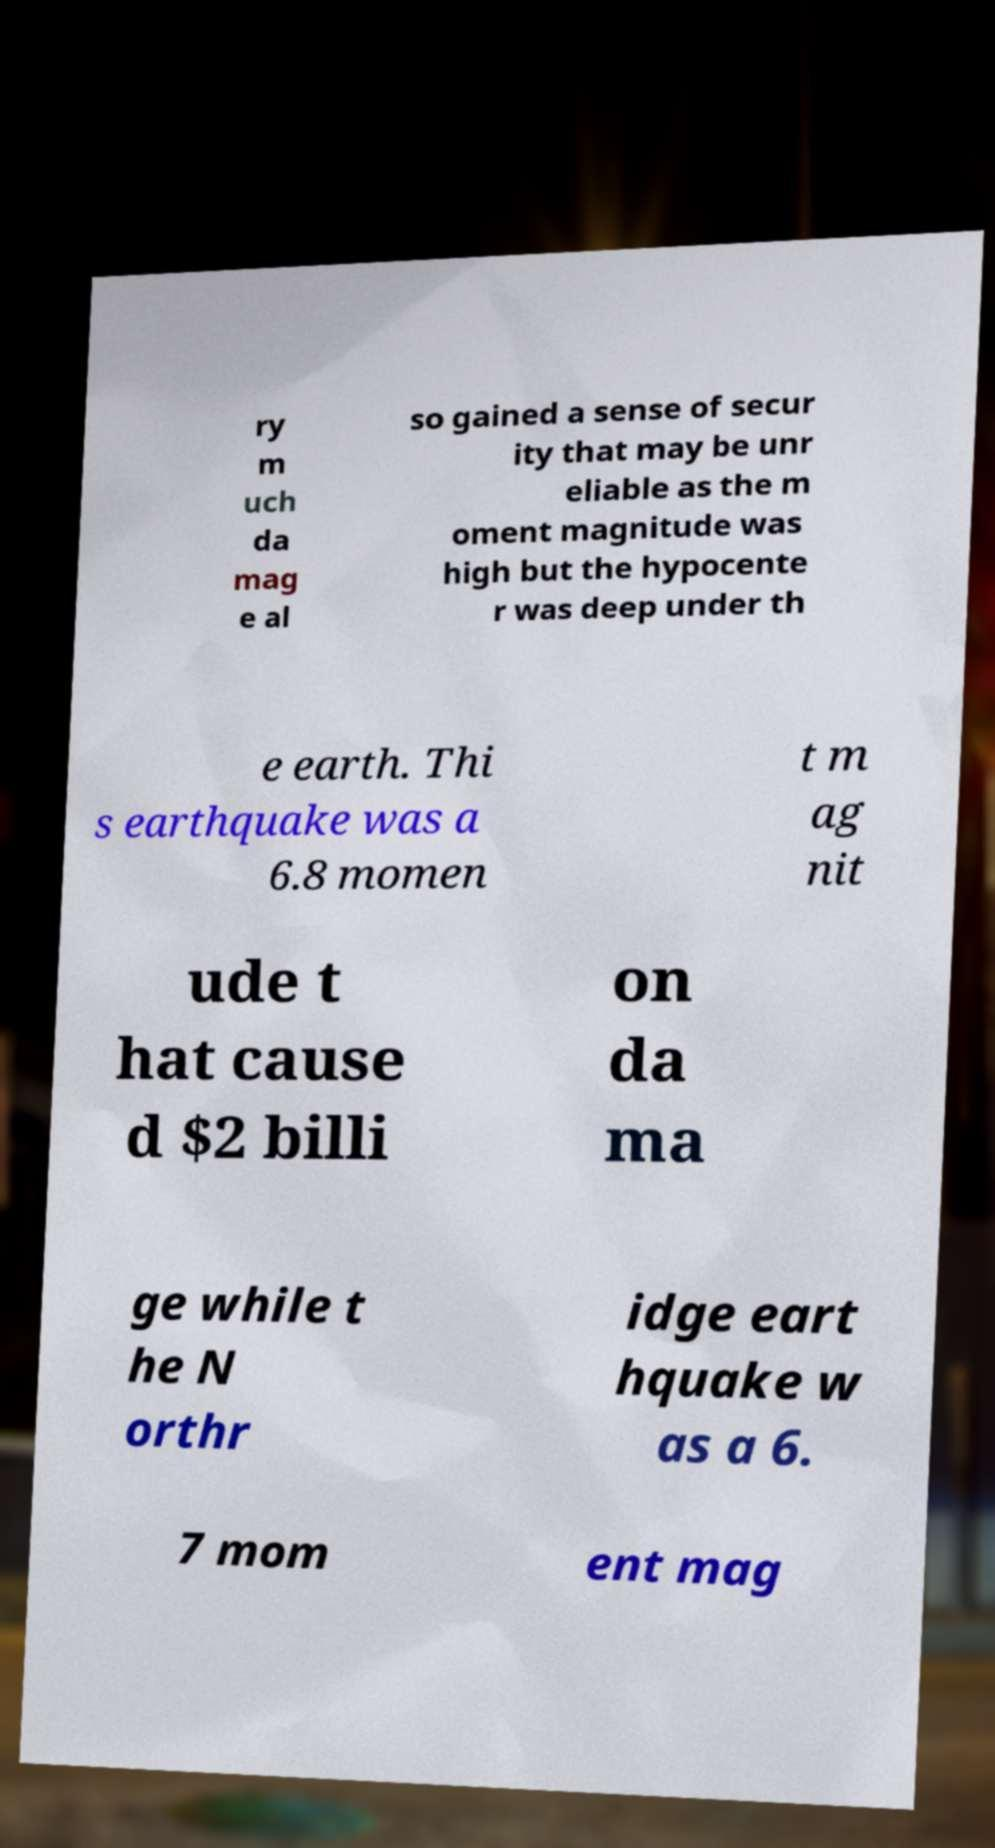Please identify and transcribe the text found in this image. ry m uch da mag e al so gained a sense of secur ity that may be unr eliable as the m oment magnitude was high but the hypocente r was deep under th e earth. Thi s earthquake was a 6.8 momen t m ag nit ude t hat cause d $2 billi on da ma ge while t he N orthr idge eart hquake w as a 6. 7 mom ent mag 